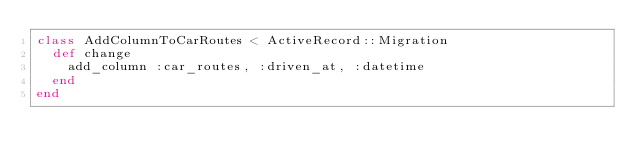Convert code to text. <code><loc_0><loc_0><loc_500><loc_500><_Ruby_>class AddColumnToCarRoutes < ActiveRecord::Migration
  def change
    add_column :car_routes, :driven_at, :datetime
  end
end
</code> 